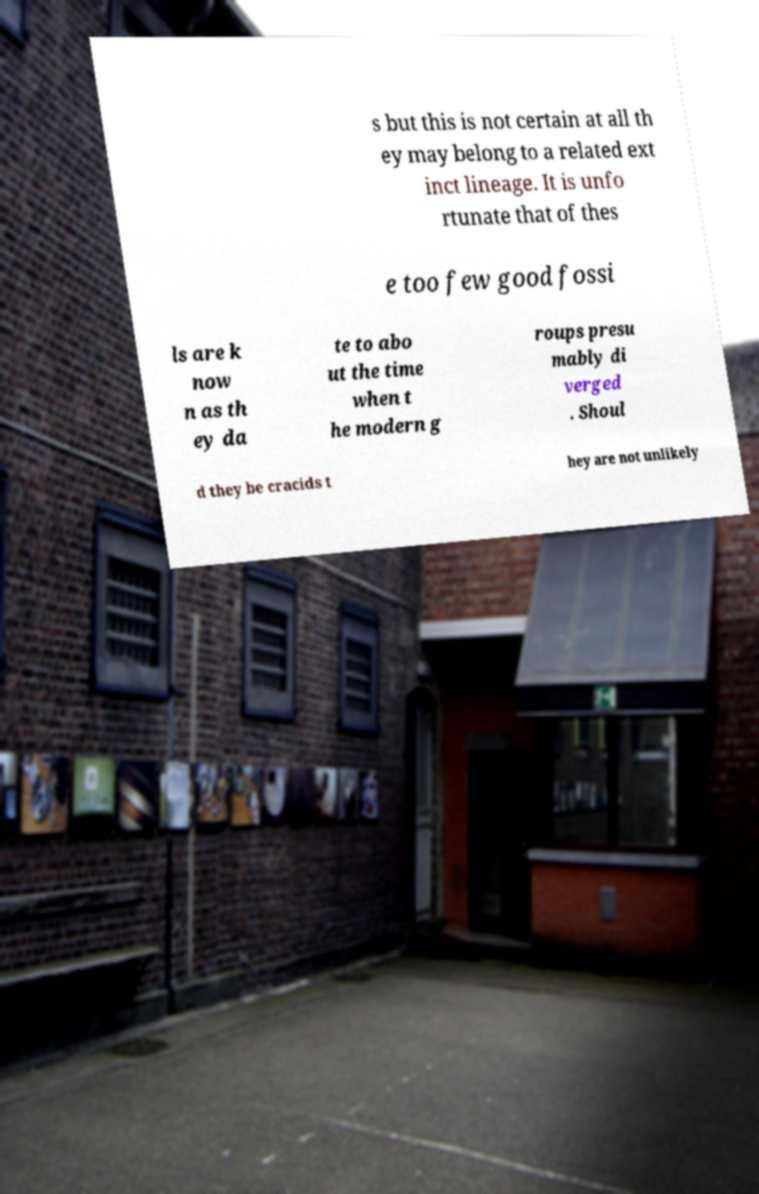There's text embedded in this image that I need extracted. Can you transcribe it verbatim? s but this is not certain at all th ey may belong to a related ext inct lineage. It is unfo rtunate that of thes e too few good fossi ls are k now n as th ey da te to abo ut the time when t he modern g roups presu mably di verged . Shoul d they be cracids t hey are not unlikely 